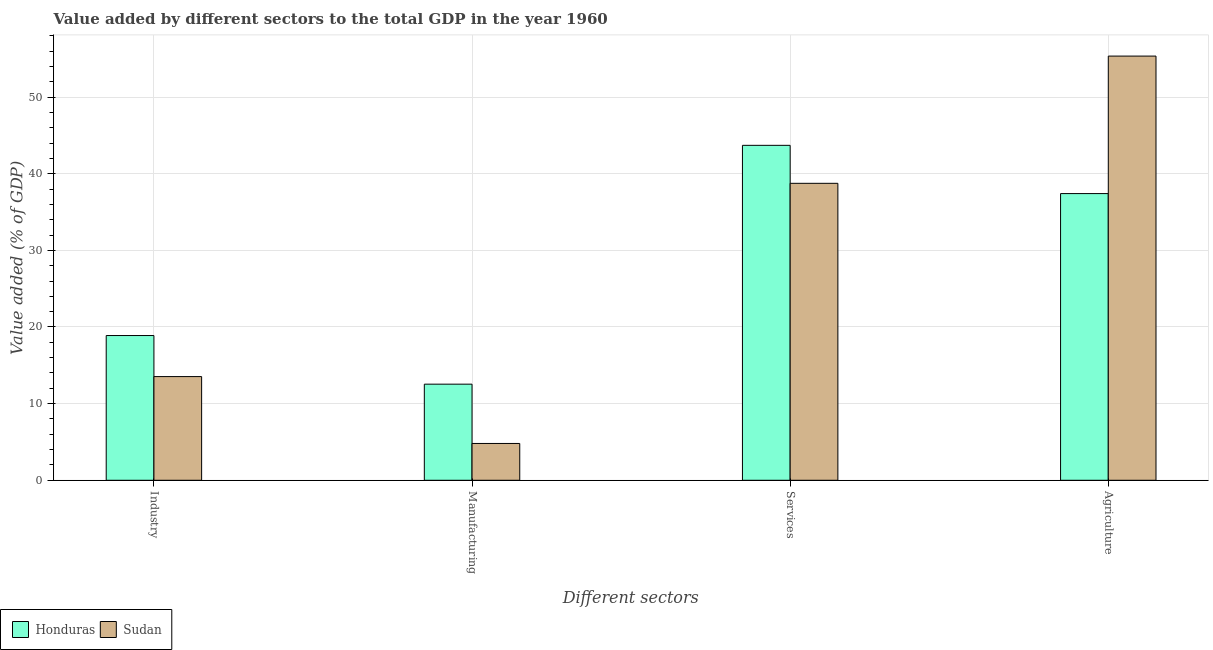Are the number of bars on each tick of the X-axis equal?
Ensure brevity in your answer.  Yes. What is the label of the 4th group of bars from the left?
Your response must be concise. Agriculture. What is the value added by services sector in Honduras?
Provide a short and direct response. 43.7. Across all countries, what is the maximum value added by services sector?
Offer a terse response. 43.7. Across all countries, what is the minimum value added by industrial sector?
Keep it short and to the point. 13.53. In which country was the value added by agricultural sector maximum?
Provide a short and direct response. Sudan. In which country was the value added by services sector minimum?
Give a very brief answer. Sudan. What is the total value added by industrial sector in the graph?
Your answer should be very brief. 32.42. What is the difference between the value added by services sector in Honduras and that in Sudan?
Make the answer very short. 4.96. What is the difference between the value added by agricultural sector in Sudan and the value added by services sector in Honduras?
Offer a terse response. 11.65. What is the average value added by agricultural sector per country?
Keep it short and to the point. 46.38. What is the difference between the value added by agricultural sector and value added by industrial sector in Sudan?
Offer a very short reply. 41.82. What is the ratio of the value added by services sector in Sudan to that in Honduras?
Your answer should be compact. 0.89. Is the value added by services sector in Sudan less than that in Honduras?
Make the answer very short. Yes. What is the difference between the highest and the second highest value added by manufacturing sector?
Offer a terse response. 7.74. What is the difference between the highest and the lowest value added by industrial sector?
Your answer should be very brief. 5.36. In how many countries, is the value added by industrial sector greater than the average value added by industrial sector taken over all countries?
Offer a terse response. 1. Is the sum of the value added by agricultural sector in Sudan and Honduras greater than the maximum value added by manufacturing sector across all countries?
Your answer should be very brief. Yes. What does the 1st bar from the left in Services represents?
Provide a short and direct response. Honduras. What does the 2nd bar from the right in Manufacturing represents?
Make the answer very short. Honduras. Is it the case that in every country, the sum of the value added by industrial sector and value added by manufacturing sector is greater than the value added by services sector?
Offer a terse response. No. How many bars are there?
Give a very brief answer. 8. Are all the bars in the graph horizontal?
Provide a short and direct response. No. What is the difference between two consecutive major ticks on the Y-axis?
Provide a short and direct response. 10. Does the graph contain grids?
Keep it short and to the point. Yes. How many legend labels are there?
Your answer should be compact. 2. What is the title of the graph?
Provide a short and direct response. Value added by different sectors to the total GDP in the year 1960. What is the label or title of the X-axis?
Your answer should be compact. Different sectors. What is the label or title of the Y-axis?
Offer a terse response. Value added (% of GDP). What is the Value added (% of GDP) of Honduras in Industry?
Make the answer very short. 18.89. What is the Value added (% of GDP) of Sudan in Industry?
Your response must be concise. 13.53. What is the Value added (% of GDP) in Honduras in Manufacturing?
Offer a very short reply. 12.54. What is the Value added (% of GDP) in Sudan in Manufacturing?
Provide a succinct answer. 4.8. What is the Value added (% of GDP) of Honduras in Services?
Give a very brief answer. 43.7. What is the Value added (% of GDP) of Sudan in Services?
Offer a terse response. 38.75. What is the Value added (% of GDP) of Honduras in Agriculture?
Your answer should be very brief. 37.41. What is the Value added (% of GDP) in Sudan in Agriculture?
Keep it short and to the point. 55.35. Across all Different sectors, what is the maximum Value added (% of GDP) in Honduras?
Your response must be concise. 43.7. Across all Different sectors, what is the maximum Value added (% of GDP) in Sudan?
Offer a terse response. 55.35. Across all Different sectors, what is the minimum Value added (% of GDP) of Honduras?
Your answer should be very brief. 12.54. Across all Different sectors, what is the minimum Value added (% of GDP) in Sudan?
Your answer should be compact. 4.8. What is the total Value added (% of GDP) in Honduras in the graph?
Keep it short and to the point. 112.54. What is the total Value added (% of GDP) in Sudan in the graph?
Your answer should be compact. 112.43. What is the difference between the Value added (% of GDP) in Honduras in Industry and that in Manufacturing?
Keep it short and to the point. 6.34. What is the difference between the Value added (% of GDP) in Sudan in Industry and that in Manufacturing?
Offer a terse response. 8.73. What is the difference between the Value added (% of GDP) of Honduras in Industry and that in Services?
Your answer should be compact. -24.82. What is the difference between the Value added (% of GDP) of Sudan in Industry and that in Services?
Provide a short and direct response. -25.22. What is the difference between the Value added (% of GDP) in Honduras in Industry and that in Agriculture?
Give a very brief answer. -18.52. What is the difference between the Value added (% of GDP) of Sudan in Industry and that in Agriculture?
Make the answer very short. -41.82. What is the difference between the Value added (% of GDP) of Honduras in Manufacturing and that in Services?
Provide a short and direct response. -31.16. What is the difference between the Value added (% of GDP) in Sudan in Manufacturing and that in Services?
Your answer should be compact. -33.95. What is the difference between the Value added (% of GDP) of Honduras in Manufacturing and that in Agriculture?
Ensure brevity in your answer.  -24.87. What is the difference between the Value added (% of GDP) of Sudan in Manufacturing and that in Agriculture?
Make the answer very short. -50.55. What is the difference between the Value added (% of GDP) in Honduras in Services and that in Agriculture?
Provide a short and direct response. 6.3. What is the difference between the Value added (% of GDP) of Sudan in Services and that in Agriculture?
Provide a succinct answer. -16.6. What is the difference between the Value added (% of GDP) of Honduras in Industry and the Value added (% of GDP) of Sudan in Manufacturing?
Your response must be concise. 14.08. What is the difference between the Value added (% of GDP) in Honduras in Industry and the Value added (% of GDP) in Sudan in Services?
Keep it short and to the point. -19.86. What is the difference between the Value added (% of GDP) in Honduras in Industry and the Value added (% of GDP) in Sudan in Agriculture?
Your response must be concise. -36.47. What is the difference between the Value added (% of GDP) of Honduras in Manufacturing and the Value added (% of GDP) of Sudan in Services?
Keep it short and to the point. -26.21. What is the difference between the Value added (% of GDP) of Honduras in Manufacturing and the Value added (% of GDP) of Sudan in Agriculture?
Provide a succinct answer. -42.81. What is the difference between the Value added (% of GDP) of Honduras in Services and the Value added (% of GDP) of Sudan in Agriculture?
Offer a terse response. -11.65. What is the average Value added (% of GDP) in Honduras per Different sectors?
Keep it short and to the point. 28.14. What is the average Value added (% of GDP) of Sudan per Different sectors?
Offer a very short reply. 28.11. What is the difference between the Value added (% of GDP) of Honduras and Value added (% of GDP) of Sudan in Industry?
Keep it short and to the point. 5.36. What is the difference between the Value added (% of GDP) of Honduras and Value added (% of GDP) of Sudan in Manufacturing?
Ensure brevity in your answer.  7.74. What is the difference between the Value added (% of GDP) of Honduras and Value added (% of GDP) of Sudan in Services?
Your answer should be compact. 4.96. What is the difference between the Value added (% of GDP) in Honduras and Value added (% of GDP) in Sudan in Agriculture?
Offer a very short reply. -17.94. What is the ratio of the Value added (% of GDP) in Honduras in Industry to that in Manufacturing?
Your response must be concise. 1.51. What is the ratio of the Value added (% of GDP) in Sudan in Industry to that in Manufacturing?
Offer a terse response. 2.82. What is the ratio of the Value added (% of GDP) in Honduras in Industry to that in Services?
Offer a terse response. 0.43. What is the ratio of the Value added (% of GDP) of Sudan in Industry to that in Services?
Your answer should be very brief. 0.35. What is the ratio of the Value added (% of GDP) in Honduras in Industry to that in Agriculture?
Your answer should be very brief. 0.5. What is the ratio of the Value added (% of GDP) in Sudan in Industry to that in Agriculture?
Your answer should be very brief. 0.24. What is the ratio of the Value added (% of GDP) of Honduras in Manufacturing to that in Services?
Your answer should be very brief. 0.29. What is the ratio of the Value added (% of GDP) of Sudan in Manufacturing to that in Services?
Ensure brevity in your answer.  0.12. What is the ratio of the Value added (% of GDP) in Honduras in Manufacturing to that in Agriculture?
Give a very brief answer. 0.34. What is the ratio of the Value added (% of GDP) of Sudan in Manufacturing to that in Agriculture?
Provide a succinct answer. 0.09. What is the ratio of the Value added (% of GDP) in Honduras in Services to that in Agriculture?
Provide a succinct answer. 1.17. What is the ratio of the Value added (% of GDP) of Sudan in Services to that in Agriculture?
Offer a very short reply. 0.7. What is the difference between the highest and the second highest Value added (% of GDP) of Honduras?
Your answer should be very brief. 6.3. What is the difference between the highest and the second highest Value added (% of GDP) in Sudan?
Your answer should be compact. 16.6. What is the difference between the highest and the lowest Value added (% of GDP) in Honduras?
Keep it short and to the point. 31.16. What is the difference between the highest and the lowest Value added (% of GDP) of Sudan?
Make the answer very short. 50.55. 